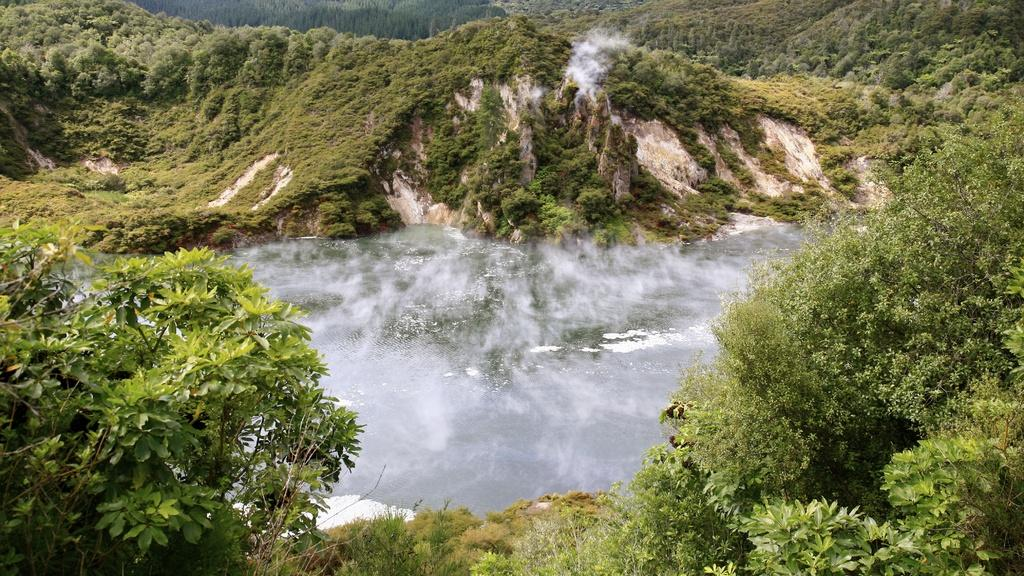What type of natural features can be seen in the image? There are trees and mountains in the image. Can you describe the weather condition in the image? There is fog in the center of the image, which suggests a misty or foggy condition. What can be seen in the background of the image? There are trees and mountains in the background of the image. Where is the drain located in the image? There is no drain present in the image. What type of balls can be seen rolling down the mountains in the image? There are no balls present in the image; it features trees, mountains, and fog. 